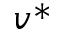<formula> <loc_0><loc_0><loc_500><loc_500>v ^ { * }</formula> 